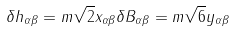Convert formula to latex. <formula><loc_0><loc_0><loc_500><loc_500>\delta h _ { \alpha \beta } = m \sqrt { 2 } x _ { \alpha \beta } \delta B _ { \alpha \beta } = m \sqrt { 6 } y _ { \alpha \beta }</formula> 